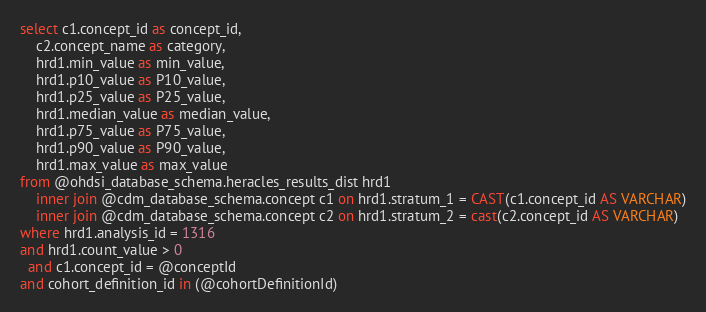<code> <loc_0><loc_0><loc_500><loc_500><_SQL_>select c1.concept_id as concept_id,
	c2.concept_name as category,
	hrd1.min_value as min_value,
	hrd1.p10_value as P10_value,
	hrd1.p25_value as P25_value,
	hrd1.median_value as median_value,
	hrd1.p75_value as P75_value,
	hrd1.p90_value as P90_value,
	hrd1.max_value as max_value
from @ohdsi_database_schema.heracles_results_dist hrd1
	inner join @cdm_database_schema.concept c1 on hrd1.stratum_1 = CAST(c1.concept_id AS VARCHAR)
	inner join @cdm_database_schema.concept c2 on hrd1.stratum_2 = cast(c2.concept_id AS VARCHAR)
where hrd1.analysis_id = 1316
and hrd1.count_value > 0
  and c1.concept_id = @conceptId
and cohort_definition_id in (@cohortDefinitionId)</code> 